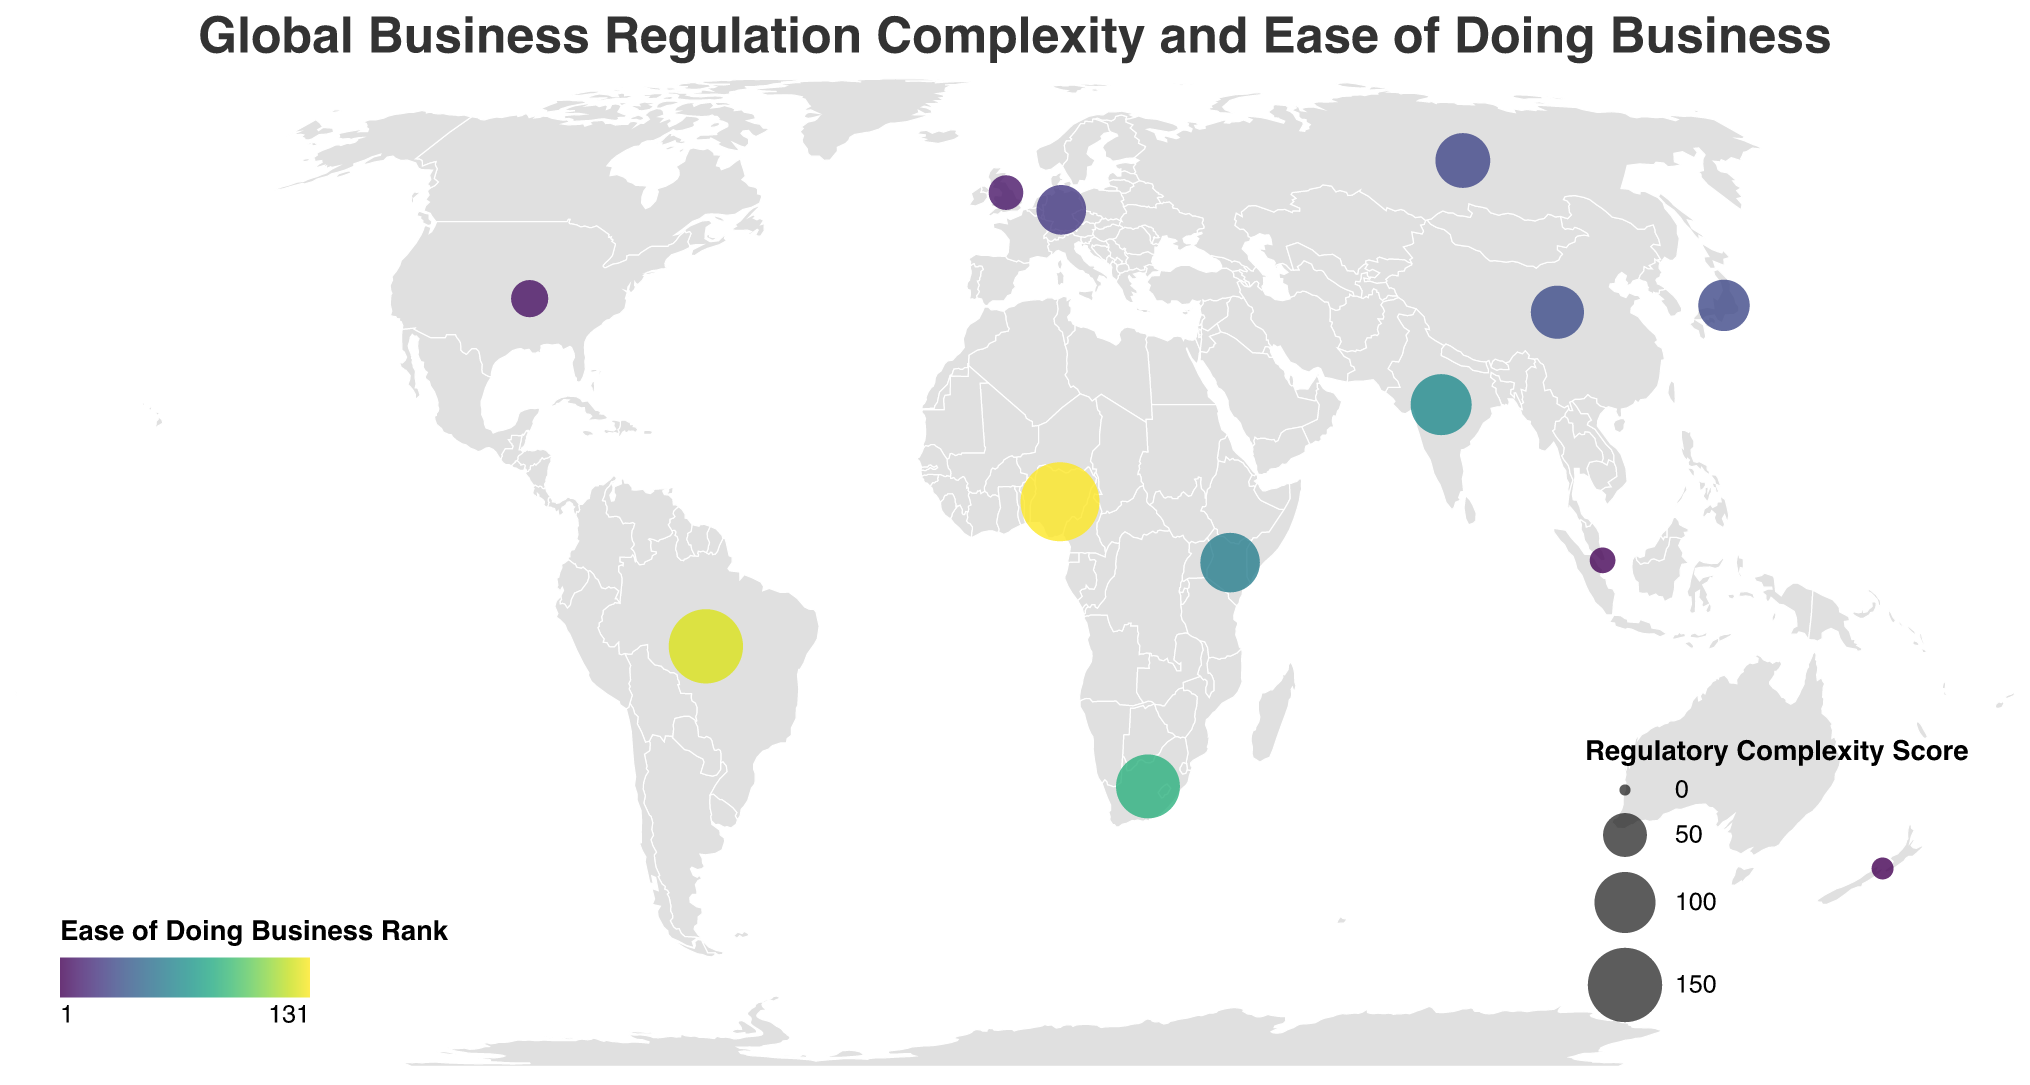How many countries are included in the figure? Count the number of distinct countries listed in the data.
Answer: 13 What is the title of the figure? Read the title displayed at the top of the figure.
Answer: Global Business Regulation Complexity and Ease of Doing Business Which country has the highest Ease of Doing Business Rank? Look for the lowest numeric value under the Ease of Doing Business Rank field, which corresponds to the highest rank.
Answer: New Zealand How does the Regulatory Complexity Score compare between India and China? Compare the Regulatory Complexity Scores for India (100) and China (75).
Answer: India has a higher score than China Which country has the lowest Regulatory Complexity Score? Look for the country with the smallest value under the Regulatory Complexity Score field.
Answer: New Zealand How many days does it take to start a business in Nigeria as compared to Germany? Compare the Days to Start a Business values: Nigeria (7 days) and Germany (8 days).
Answer: It takes fewer days in Nigeria Which country requires the fewest number of permits to start a new business? Identify the country with the smallest number of "Permits Required for New Business".
Answer: New Zealand What is the relationship between Ease of Doing Business Rank and Regulatory Complexity Score in Brazil? Locate Brazil's data points and check the Ease of Doing Business Rank (124) and Regulatory Complexity Score (150). Higher rank number indicates more difficulty, and higher complexity score indicates more complexity.
Answer: Both are high, indicating difficulty and complexity Between South Africa and Kenya, which country has a higher Regulatory Complexity Score? Compare the Regulatory Complexity Scores of South Africa (110) and Kenya (95).
Answer: South Africa has a higher score How does New Zealand's regulatory environment compare to the United States' in terms of the number of days to start a business and the number of required permits? Find and compare the values: New Zealand (0.5 days, 2 permits) vs. United States (4 days, 5 permits).
Answer: New Zealand is much quicker and requires fewer permits 